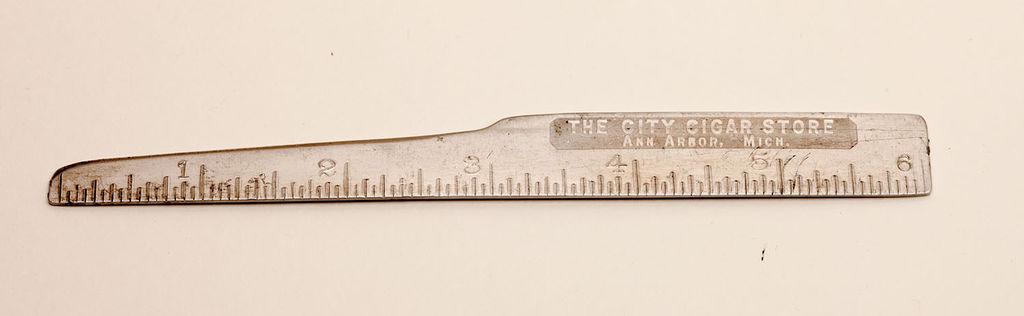What kind of store is this from?
Your answer should be compact. Cigar. 